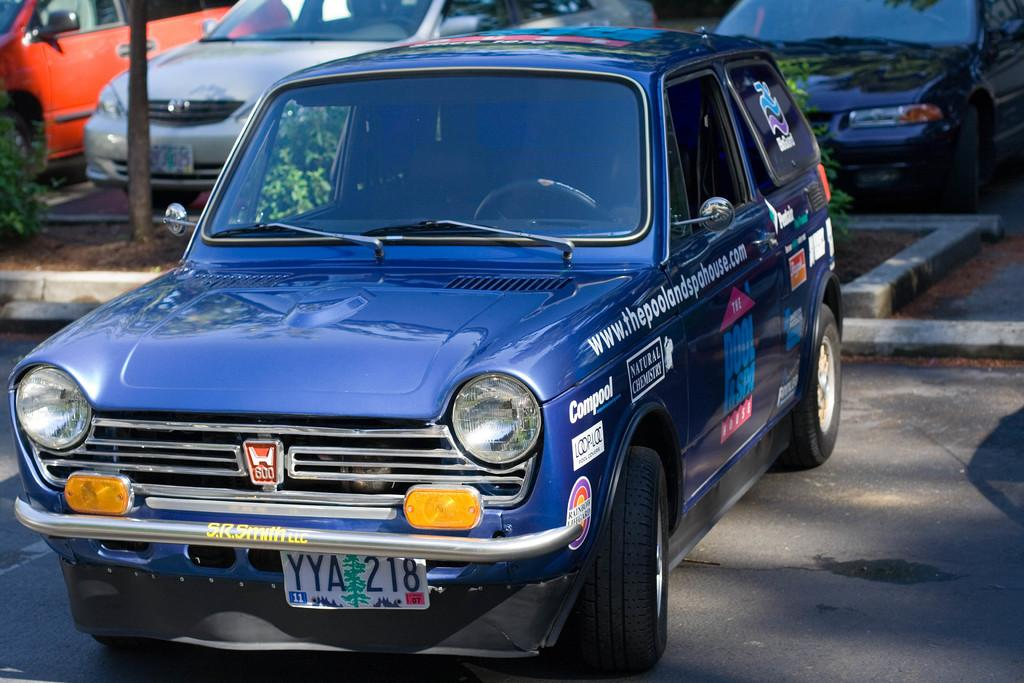What can be seen on the road in the image? There are cars on the road in the image. What separates the lanes of traffic on the road? There is a divider in the middle of the road. What is on top of the divider? The divider has plants on it. What else can be seen on the divider? There is a pole on the divider. What type of haircut is the divider giving to the cars in the image? The divider is not giving a haircut to the cars in the image; it is a physical barrier separating the lanes of traffic. 